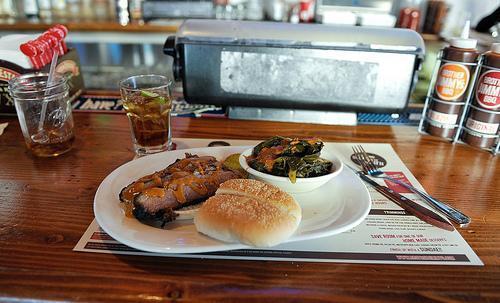How many utensils near the plate?
Give a very brief answer. 2. How many squeeze bottles with orange labels?
Give a very brief answer. 1. How many glasses are next to the plate of food?
Give a very brief answer. 2. 